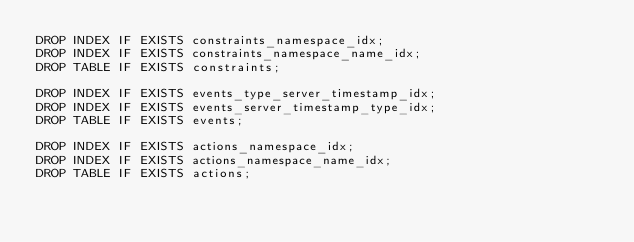Convert code to text. <code><loc_0><loc_0><loc_500><loc_500><_SQL_>DROP INDEX IF EXISTS constraints_namespace_idx;
DROP INDEX IF EXISTS constraints_namespace_name_idx;
DROP TABLE IF EXISTS constraints;

DROP INDEX IF EXISTS events_type_server_timestamp_idx;
DROP INDEX IF EXISTS events_server_timestamp_type_idx;
DROP TABLE IF EXISTS events;

DROP INDEX IF EXISTS actions_namespace_idx;
DROP INDEX IF EXISTS actions_namespace_name_idx;
DROP TABLE IF EXISTS actions;
</code> 